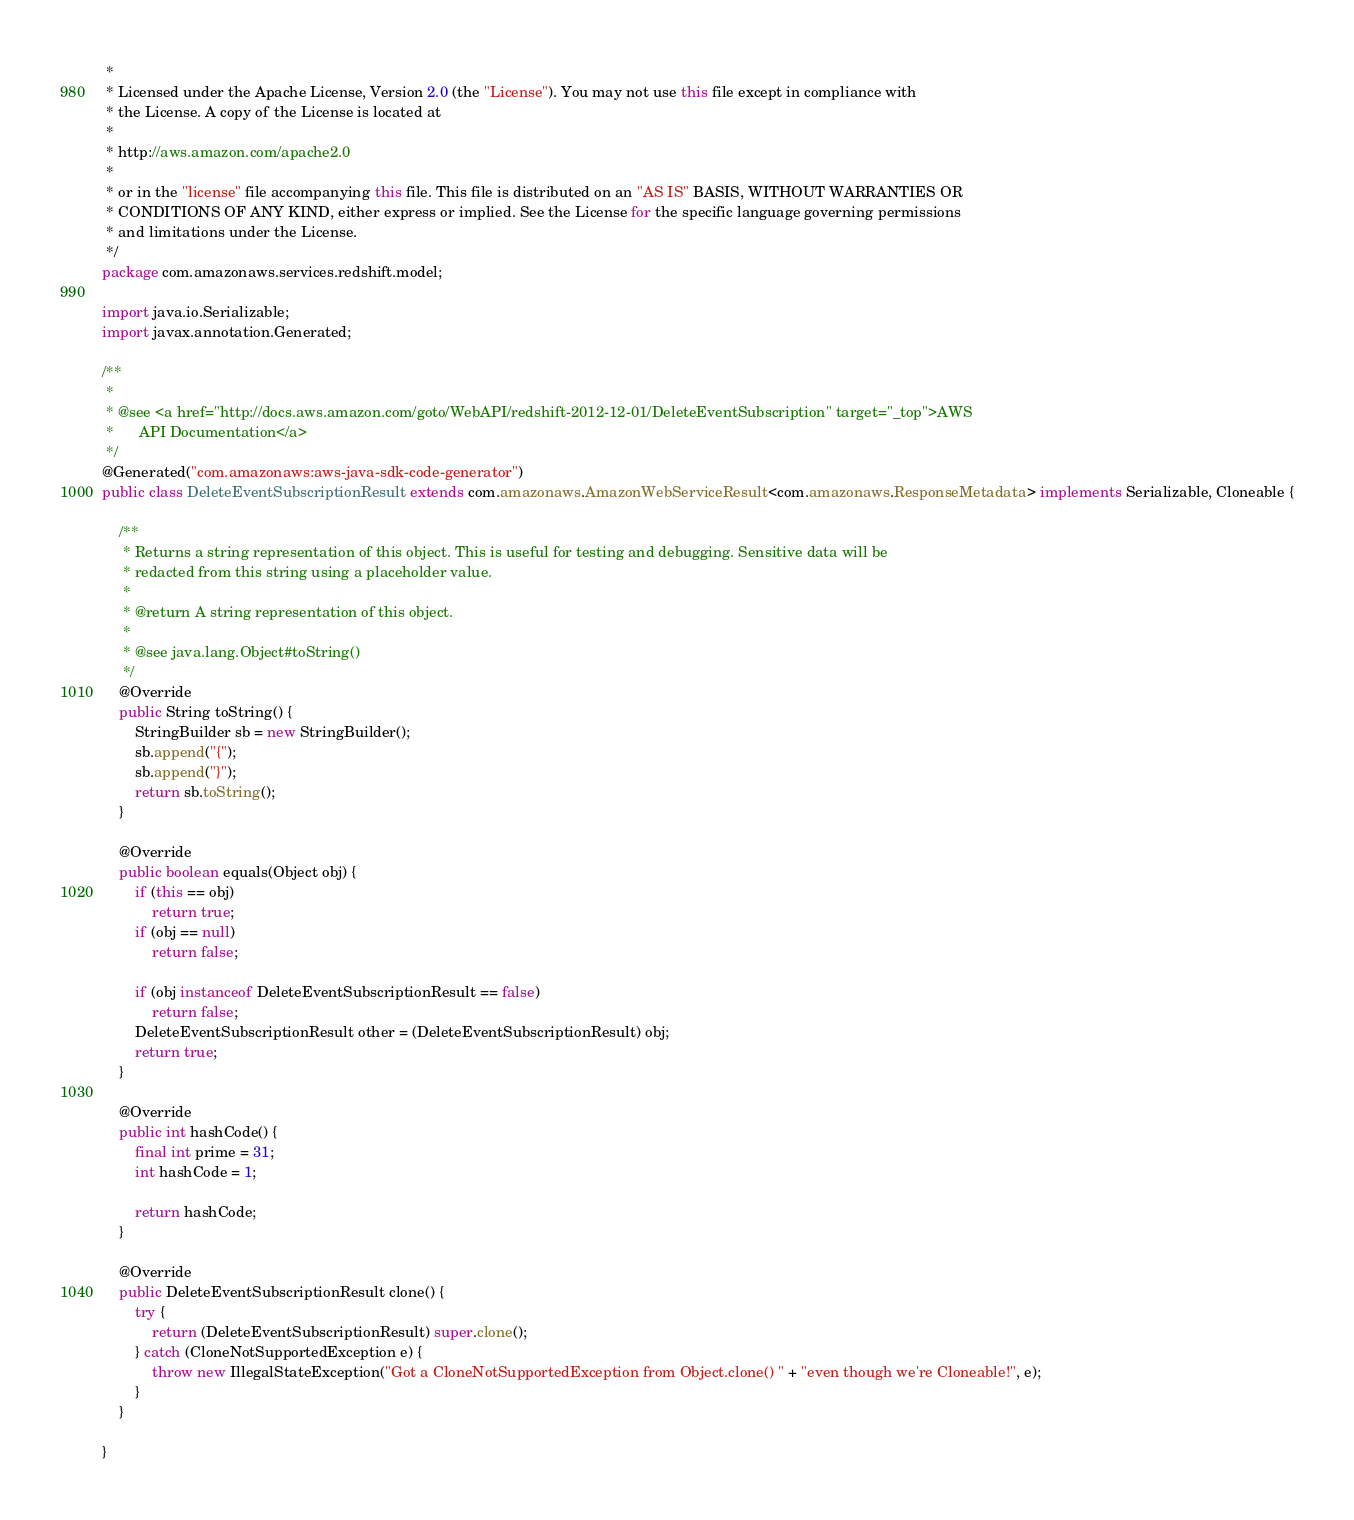<code> <loc_0><loc_0><loc_500><loc_500><_Java_> * 
 * Licensed under the Apache License, Version 2.0 (the "License"). You may not use this file except in compliance with
 * the License. A copy of the License is located at
 * 
 * http://aws.amazon.com/apache2.0
 * 
 * or in the "license" file accompanying this file. This file is distributed on an "AS IS" BASIS, WITHOUT WARRANTIES OR
 * CONDITIONS OF ANY KIND, either express or implied. See the License for the specific language governing permissions
 * and limitations under the License.
 */
package com.amazonaws.services.redshift.model;

import java.io.Serializable;
import javax.annotation.Generated;

/**
 * 
 * @see <a href="http://docs.aws.amazon.com/goto/WebAPI/redshift-2012-12-01/DeleteEventSubscription" target="_top">AWS
 *      API Documentation</a>
 */
@Generated("com.amazonaws:aws-java-sdk-code-generator")
public class DeleteEventSubscriptionResult extends com.amazonaws.AmazonWebServiceResult<com.amazonaws.ResponseMetadata> implements Serializable, Cloneable {

    /**
     * Returns a string representation of this object. This is useful for testing and debugging. Sensitive data will be
     * redacted from this string using a placeholder value.
     *
     * @return A string representation of this object.
     *
     * @see java.lang.Object#toString()
     */
    @Override
    public String toString() {
        StringBuilder sb = new StringBuilder();
        sb.append("{");
        sb.append("}");
        return sb.toString();
    }

    @Override
    public boolean equals(Object obj) {
        if (this == obj)
            return true;
        if (obj == null)
            return false;

        if (obj instanceof DeleteEventSubscriptionResult == false)
            return false;
        DeleteEventSubscriptionResult other = (DeleteEventSubscriptionResult) obj;
        return true;
    }

    @Override
    public int hashCode() {
        final int prime = 31;
        int hashCode = 1;

        return hashCode;
    }

    @Override
    public DeleteEventSubscriptionResult clone() {
        try {
            return (DeleteEventSubscriptionResult) super.clone();
        } catch (CloneNotSupportedException e) {
            throw new IllegalStateException("Got a CloneNotSupportedException from Object.clone() " + "even though we're Cloneable!", e);
        }
    }

}
</code> 